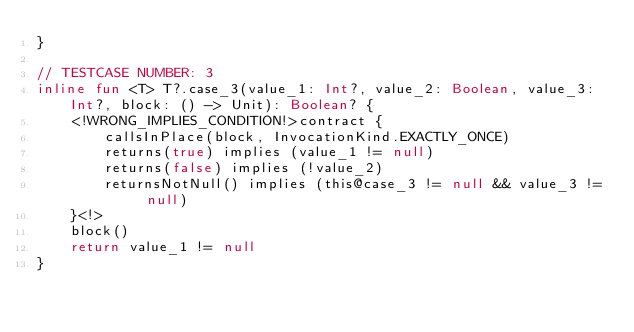Convert code to text. <code><loc_0><loc_0><loc_500><loc_500><_Kotlin_>}

// TESTCASE NUMBER: 3
inline fun <T> T?.case_3(value_1: Int?, value_2: Boolean, value_3: Int?, block: () -> Unit): Boolean? {
    <!WRONG_IMPLIES_CONDITION!>contract {
        callsInPlace(block, InvocationKind.EXACTLY_ONCE)
        returns(true) implies (value_1 != null)
        returns(false) implies (!value_2)
        returnsNotNull() implies (this@case_3 != null && value_3 != null)
    }<!>
    block()
    return value_1 != null
}
</code> 